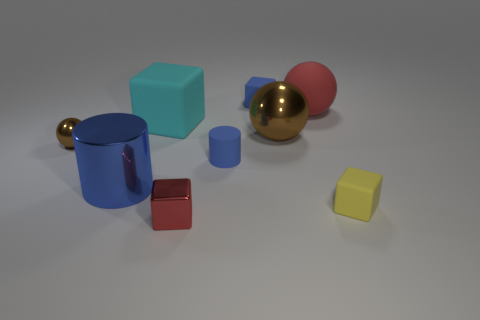Add 1 tiny red metallic blocks. How many objects exist? 10 Subtract all large brown spheres. How many spheres are left? 2 Subtract 0 cyan spheres. How many objects are left? 9 Subtract all cylinders. How many objects are left? 7 Subtract 2 balls. How many balls are left? 1 Subtract all purple cubes. Subtract all brown spheres. How many cubes are left? 4 Subtract all green balls. How many yellow blocks are left? 1 Subtract all red things. Subtract all big blocks. How many objects are left? 6 Add 6 large balls. How many large balls are left? 8 Add 6 matte cylinders. How many matte cylinders exist? 7 